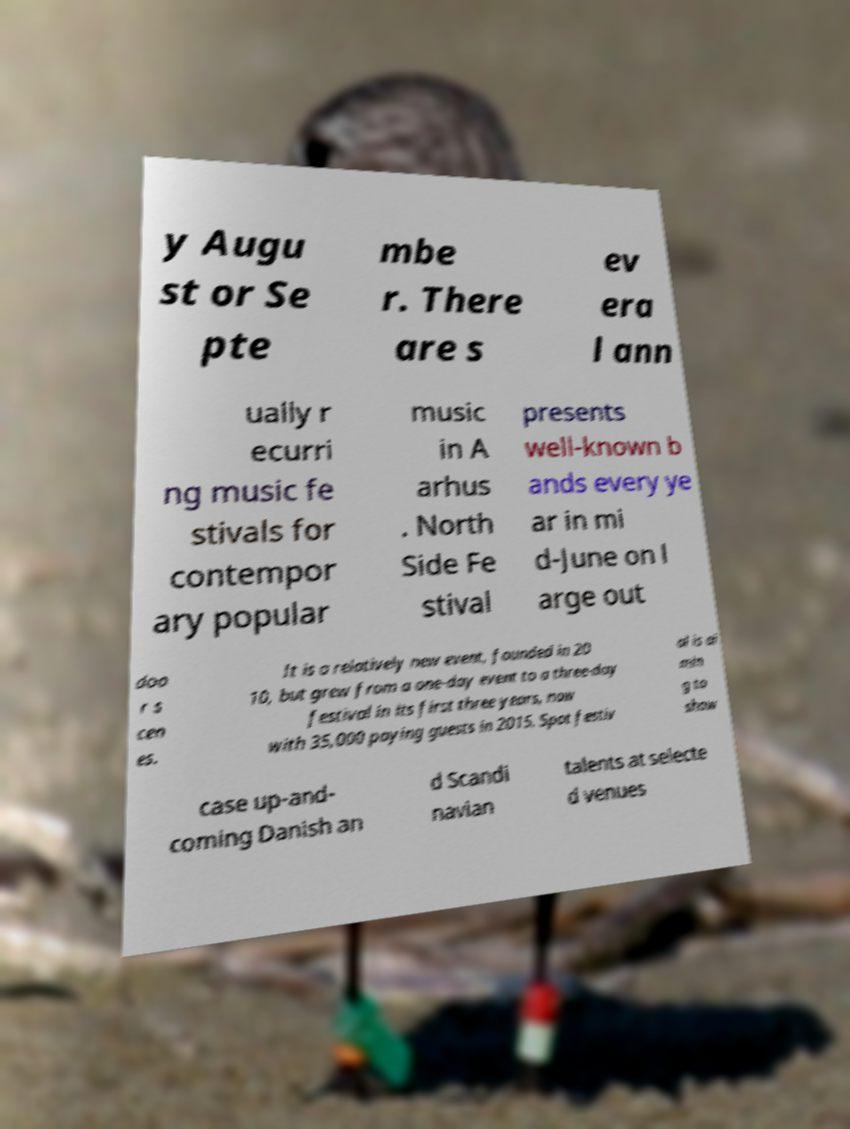There's text embedded in this image that I need extracted. Can you transcribe it verbatim? y Augu st or Se pte mbe r. There are s ev era l ann ually r ecurri ng music fe stivals for contempor ary popular music in A arhus . North Side Fe stival presents well-known b ands every ye ar in mi d-June on l arge out doo r s cen es. It is a relatively new event, founded in 20 10, but grew from a one-day event to a three-day festival in its first three years, now with 35,000 paying guests in 2015. Spot festiv al is ai min g to show case up-and- coming Danish an d Scandi navian talents at selecte d venues 